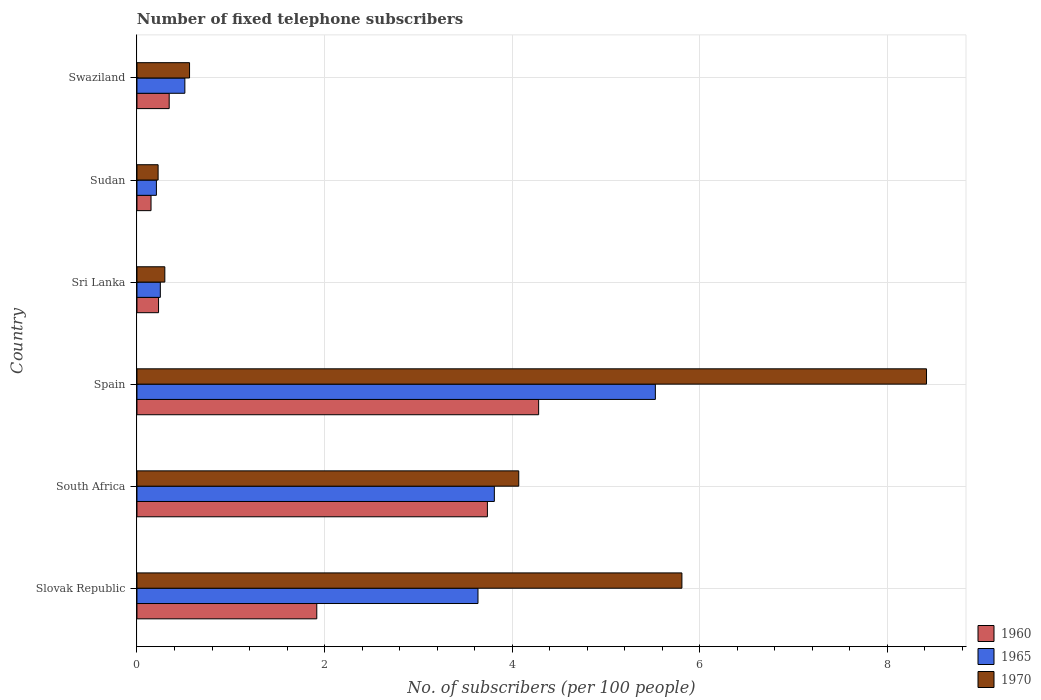How many groups of bars are there?
Keep it short and to the point. 6. Are the number of bars on each tick of the Y-axis equal?
Your answer should be compact. Yes. How many bars are there on the 4th tick from the top?
Provide a short and direct response. 3. What is the label of the 5th group of bars from the top?
Your response must be concise. South Africa. What is the number of fixed telephone subscribers in 1960 in Sudan?
Give a very brief answer. 0.15. Across all countries, what is the maximum number of fixed telephone subscribers in 1960?
Make the answer very short. 4.28. Across all countries, what is the minimum number of fixed telephone subscribers in 1960?
Offer a terse response. 0.15. In which country was the number of fixed telephone subscribers in 1970 maximum?
Offer a terse response. Spain. In which country was the number of fixed telephone subscribers in 1970 minimum?
Your response must be concise. Sudan. What is the total number of fixed telephone subscribers in 1970 in the graph?
Ensure brevity in your answer.  19.38. What is the difference between the number of fixed telephone subscribers in 1965 in Slovak Republic and that in Sri Lanka?
Provide a succinct answer. 3.39. What is the difference between the number of fixed telephone subscribers in 1965 in Spain and the number of fixed telephone subscribers in 1970 in South Africa?
Give a very brief answer. 1.46. What is the average number of fixed telephone subscribers in 1960 per country?
Your answer should be compact. 1.78. What is the difference between the number of fixed telephone subscribers in 1965 and number of fixed telephone subscribers in 1970 in Spain?
Your answer should be very brief. -2.89. What is the ratio of the number of fixed telephone subscribers in 1970 in South Africa to that in Swaziland?
Keep it short and to the point. 7.26. What is the difference between the highest and the second highest number of fixed telephone subscribers in 1960?
Your answer should be compact. 0.55. What is the difference between the highest and the lowest number of fixed telephone subscribers in 1960?
Your response must be concise. 4.13. What does the 3rd bar from the top in South Africa represents?
Your response must be concise. 1960. What does the 1st bar from the bottom in Sri Lanka represents?
Your answer should be compact. 1960. Is it the case that in every country, the sum of the number of fixed telephone subscribers in 1960 and number of fixed telephone subscribers in 1970 is greater than the number of fixed telephone subscribers in 1965?
Make the answer very short. Yes. Are all the bars in the graph horizontal?
Give a very brief answer. Yes. Does the graph contain any zero values?
Keep it short and to the point. No. Where does the legend appear in the graph?
Give a very brief answer. Bottom right. What is the title of the graph?
Make the answer very short. Number of fixed telephone subscribers. Does "1964" appear as one of the legend labels in the graph?
Make the answer very short. No. What is the label or title of the X-axis?
Your response must be concise. No. of subscribers (per 100 people). What is the label or title of the Y-axis?
Your response must be concise. Country. What is the No. of subscribers (per 100 people) in 1960 in Slovak Republic?
Make the answer very short. 1.92. What is the No. of subscribers (per 100 people) of 1965 in Slovak Republic?
Make the answer very short. 3.64. What is the No. of subscribers (per 100 people) of 1970 in Slovak Republic?
Provide a succinct answer. 5.81. What is the No. of subscribers (per 100 people) in 1960 in South Africa?
Provide a short and direct response. 3.74. What is the No. of subscribers (per 100 people) in 1965 in South Africa?
Keep it short and to the point. 3.81. What is the No. of subscribers (per 100 people) of 1970 in South Africa?
Your answer should be compact. 4.07. What is the No. of subscribers (per 100 people) in 1960 in Spain?
Provide a succinct answer. 4.28. What is the No. of subscribers (per 100 people) in 1965 in Spain?
Provide a succinct answer. 5.53. What is the No. of subscribers (per 100 people) of 1970 in Spain?
Your response must be concise. 8.42. What is the No. of subscribers (per 100 people) of 1960 in Sri Lanka?
Your answer should be very brief. 0.23. What is the No. of subscribers (per 100 people) of 1965 in Sri Lanka?
Your answer should be very brief. 0.25. What is the No. of subscribers (per 100 people) of 1970 in Sri Lanka?
Make the answer very short. 0.3. What is the No. of subscribers (per 100 people) of 1960 in Sudan?
Your answer should be compact. 0.15. What is the No. of subscribers (per 100 people) of 1965 in Sudan?
Make the answer very short. 0.21. What is the No. of subscribers (per 100 people) in 1970 in Sudan?
Ensure brevity in your answer.  0.23. What is the No. of subscribers (per 100 people) of 1960 in Swaziland?
Your response must be concise. 0.34. What is the No. of subscribers (per 100 people) in 1965 in Swaziland?
Offer a very short reply. 0.51. What is the No. of subscribers (per 100 people) of 1970 in Swaziland?
Offer a very short reply. 0.56. Across all countries, what is the maximum No. of subscribers (per 100 people) in 1960?
Make the answer very short. 4.28. Across all countries, what is the maximum No. of subscribers (per 100 people) of 1965?
Make the answer very short. 5.53. Across all countries, what is the maximum No. of subscribers (per 100 people) of 1970?
Your response must be concise. 8.42. Across all countries, what is the minimum No. of subscribers (per 100 people) of 1960?
Offer a terse response. 0.15. Across all countries, what is the minimum No. of subscribers (per 100 people) of 1965?
Ensure brevity in your answer.  0.21. Across all countries, what is the minimum No. of subscribers (per 100 people) in 1970?
Give a very brief answer. 0.23. What is the total No. of subscribers (per 100 people) of 1960 in the graph?
Your answer should be very brief. 10.66. What is the total No. of subscribers (per 100 people) in 1965 in the graph?
Keep it short and to the point. 13.94. What is the total No. of subscribers (per 100 people) of 1970 in the graph?
Provide a short and direct response. 19.38. What is the difference between the No. of subscribers (per 100 people) of 1960 in Slovak Republic and that in South Africa?
Your answer should be very brief. -1.82. What is the difference between the No. of subscribers (per 100 people) in 1965 in Slovak Republic and that in South Africa?
Your response must be concise. -0.17. What is the difference between the No. of subscribers (per 100 people) of 1970 in Slovak Republic and that in South Africa?
Ensure brevity in your answer.  1.74. What is the difference between the No. of subscribers (per 100 people) in 1960 in Slovak Republic and that in Spain?
Offer a terse response. -2.37. What is the difference between the No. of subscribers (per 100 people) of 1965 in Slovak Republic and that in Spain?
Your answer should be compact. -1.89. What is the difference between the No. of subscribers (per 100 people) in 1970 in Slovak Republic and that in Spain?
Offer a very short reply. -2.61. What is the difference between the No. of subscribers (per 100 people) of 1960 in Slovak Republic and that in Sri Lanka?
Make the answer very short. 1.69. What is the difference between the No. of subscribers (per 100 people) in 1965 in Slovak Republic and that in Sri Lanka?
Offer a very short reply. 3.39. What is the difference between the No. of subscribers (per 100 people) in 1970 in Slovak Republic and that in Sri Lanka?
Make the answer very short. 5.51. What is the difference between the No. of subscribers (per 100 people) of 1960 in Slovak Republic and that in Sudan?
Make the answer very short. 1.77. What is the difference between the No. of subscribers (per 100 people) of 1965 in Slovak Republic and that in Sudan?
Provide a succinct answer. 3.43. What is the difference between the No. of subscribers (per 100 people) in 1970 in Slovak Republic and that in Sudan?
Give a very brief answer. 5.58. What is the difference between the No. of subscribers (per 100 people) in 1960 in Slovak Republic and that in Swaziland?
Provide a succinct answer. 1.57. What is the difference between the No. of subscribers (per 100 people) in 1965 in Slovak Republic and that in Swaziland?
Keep it short and to the point. 3.13. What is the difference between the No. of subscribers (per 100 people) in 1970 in Slovak Republic and that in Swaziland?
Your answer should be very brief. 5.25. What is the difference between the No. of subscribers (per 100 people) of 1960 in South Africa and that in Spain?
Your response must be concise. -0.55. What is the difference between the No. of subscribers (per 100 people) in 1965 in South Africa and that in Spain?
Offer a very short reply. -1.72. What is the difference between the No. of subscribers (per 100 people) in 1970 in South Africa and that in Spain?
Your response must be concise. -4.35. What is the difference between the No. of subscribers (per 100 people) in 1960 in South Africa and that in Sri Lanka?
Offer a terse response. 3.51. What is the difference between the No. of subscribers (per 100 people) of 1965 in South Africa and that in Sri Lanka?
Provide a succinct answer. 3.56. What is the difference between the No. of subscribers (per 100 people) of 1970 in South Africa and that in Sri Lanka?
Your answer should be compact. 3.77. What is the difference between the No. of subscribers (per 100 people) of 1960 in South Africa and that in Sudan?
Your answer should be very brief. 3.59. What is the difference between the No. of subscribers (per 100 people) of 1965 in South Africa and that in Sudan?
Keep it short and to the point. 3.6. What is the difference between the No. of subscribers (per 100 people) in 1970 in South Africa and that in Sudan?
Give a very brief answer. 3.85. What is the difference between the No. of subscribers (per 100 people) of 1960 in South Africa and that in Swaziland?
Your answer should be compact. 3.39. What is the difference between the No. of subscribers (per 100 people) in 1965 in South Africa and that in Swaziland?
Your answer should be compact. 3.3. What is the difference between the No. of subscribers (per 100 people) of 1970 in South Africa and that in Swaziland?
Make the answer very short. 3.51. What is the difference between the No. of subscribers (per 100 people) in 1960 in Spain and that in Sri Lanka?
Keep it short and to the point. 4.05. What is the difference between the No. of subscribers (per 100 people) in 1965 in Spain and that in Sri Lanka?
Provide a succinct answer. 5.28. What is the difference between the No. of subscribers (per 100 people) of 1970 in Spain and that in Sri Lanka?
Provide a short and direct response. 8.12. What is the difference between the No. of subscribers (per 100 people) in 1960 in Spain and that in Sudan?
Offer a very short reply. 4.13. What is the difference between the No. of subscribers (per 100 people) in 1965 in Spain and that in Sudan?
Keep it short and to the point. 5.32. What is the difference between the No. of subscribers (per 100 people) in 1970 in Spain and that in Sudan?
Provide a succinct answer. 8.19. What is the difference between the No. of subscribers (per 100 people) in 1960 in Spain and that in Swaziland?
Ensure brevity in your answer.  3.94. What is the difference between the No. of subscribers (per 100 people) in 1965 in Spain and that in Swaziland?
Give a very brief answer. 5.02. What is the difference between the No. of subscribers (per 100 people) in 1970 in Spain and that in Swaziland?
Offer a terse response. 7.86. What is the difference between the No. of subscribers (per 100 people) in 1960 in Sri Lanka and that in Sudan?
Offer a very short reply. 0.08. What is the difference between the No. of subscribers (per 100 people) in 1965 in Sri Lanka and that in Sudan?
Ensure brevity in your answer.  0.04. What is the difference between the No. of subscribers (per 100 people) of 1970 in Sri Lanka and that in Sudan?
Provide a succinct answer. 0.07. What is the difference between the No. of subscribers (per 100 people) of 1960 in Sri Lanka and that in Swaziland?
Provide a succinct answer. -0.11. What is the difference between the No. of subscribers (per 100 people) of 1965 in Sri Lanka and that in Swaziland?
Provide a short and direct response. -0.26. What is the difference between the No. of subscribers (per 100 people) of 1970 in Sri Lanka and that in Swaziland?
Your answer should be compact. -0.26. What is the difference between the No. of subscribers (per 100 people) in 1960 in Sudan and that in Swaziland?
Provide a short and direct response. -0.19. What is the difference between the No. of subscribers (per 100 people) of 1965 in Sudan and that in Swaziland?
Provide a succinct answer. -0.3. What is the difference between the No. of subscribers (per 100 people) in 1970 in Sudan and that in Swaziland?
Your response must be concise. -0.34. What is the difference between the No. of subscribers (per 100 people) in 1960 in Slovak Republic and the No. of subscribers (per 100 people) in 1965 in South Africa?
Your answer should be very brief. -1.89. What is the difference between the No. of subscribers (per 100 people) of 1960 in Slovak Republic and the No. of subscribers (per 100 people) of 1970 in South Africa?
Offer a terse response. -2.15. What is the difference between the No. of subscribers (per 100 people) in 1965 in Slovak Republic and the No. of subscribers (per 100 people) in 1970 in South Africa?
Give a very brief answer. -0.43. What is the difference between the No. of subscribers (per 100 people) in 1960 in Slovak Republic and the No. of subscribers (per 100 people) in 1965 in Spain?
Keep it short and to the point. -3.61. What is the difference between the No. of subscribers (per 100 people) of 1960 in Slovak Republic and the No. of subscribers (per 100 people) of 1970 in Spain?
Offer a terse response. -6.5. What is the difference between the No. of subscribers (per 100 people) of 1965 in Slovak Republic and the No. of subscribers (per 100 people) of 1970 in Spain?
Provide a short and direct response. -4.78. What is the difference between the No. of subscribers (per 100 people) in 1960 in Slovak Republic and the No. of subscribers (per 100 people) in 1965 in Sri Lanka?
Keep it short and to the point. 1.67. What is the difference between the No. of subscribers (per 100 people) of 1960 in Slovak Republic and the No. of subscribers (per 100 people) of 1970 in Sri Lanka?
Ensure brevity in your answer.  1.62. What is the difference between the No. of subscribers (per 100 people) of 1965 in Slovak Republic and the No. of subscribers (per 100 people) of 1970 in Sri Lanka?
Keep it short and to the point. 3.34. What is the difference between the No. of subscribers (per 100 people) in 1960 in Slovak Republic and the No. of subscribers (per 100 people) in 1965 in Sudan?
Ensure brevity in your answer.  1.71. What is the difference between the No. of subscribers (per 100 people) in 1960 in Slovak Republic and the No. of subscribers (per 100 people) in 1970 in Sudan?
Give a very brief answer. 1.69. What is the difference between the No. of subscribers (per 100 people) of 1965 in Slovak Republic and the No. of subscribers (per 100 people) of 1970 in Sudan?
Give a very brief answer. 3.41. What is the difference between the No. of subscribers (per 100 people) of 1960 in Slovak Republic and the No. of subscribers (per 100 people) of 1965 in Swaziland?
Provide a short and direct response. 1.41. What is the difference between the No. of subscribers (per 100 people) in 1960 in Slovak Republic and the No. of subscribers (per 100 people) in 1970 in Swaziland?
Ensure brevity in your answer.  1.36. What is the difference between the No. of subscribers (per 100 people) in 1965 in Slovak Republic and the No. of subscribers (per 100 people) in 1970 in Swaziland?
Offer a very short reply. 3.08. What is the difference between the No. of subscribers (per 100 people) in 1960 in South Africa and the No. of subscribers (per 100 people) in 1965 in Spain?
Offer a terse response. -1.79. What is the difference between the No. of subscribers (per 100 people) in 1960 in South Africa and the No. of subscribers (per 100 people) in 1970 in Spain?
Ensure brevity in your answer.  -4.68. What is the difference between the No. of subscribers (per 100 people) of 1965 in South Africa and the No. of subscribers (per 100 people) of 1970 in Spain?
Your response must be concise. -4.61. What is the difference between the No. of subscribers (per 100 people) in 1960 in South Africa and the No. of subscribers (per 100 people) in 1965 in Sri Lanka?
Make the answer very short. 3.49. What is the difference between the No. of subscribers (per 100 people) of 1960 in South Africa and the No. of subscribers (per 100 people) of 1970 in Sri Lanka?
Your response must be concise. 3.44. What is the difference between the No. of subscribers (per 100 people) of 1965 in South Africa and the No. of subscribers (per 100 people) of 1970 in Sri Lanka?
Provide a succinct answer. 3.51. What is the difference between the No. of subscribers (per 100 people) of 1960 in South Africa and the No. of subscribers (per 100 people) of 1965 in Sudan?
Ensure brevity in your answer.  3.53. What is the difference between the No. of subscribers (per 100 people) of 1960 in South Africa and the No. of subscribers (per 100 people) of 1970 in Sudan?
Your answer should be very brief. 3.51. What is the difference between the No. of subscribers (per 100 people) of 1965 in South Africa and the No. of subscribers (per 100 people) of 1970 in Sudan?
Offer a terse response. 3.58. What is the difference between the No. of subscribers (per 100 people) in 1960 in South Africa and the No. of subscribers (per 100 people) in 1965 in Swaziland?
Your answer should be very brief. 3.23. What is the difference between the No. of subscribers (per 100 people) of 1960 in South Africa and the No. of subscribers (per 100 people) of 1970 in Swaziland?
Give a very brief answer. 3.18. What is the difference between the No. of subscribers (per 100 people) of 1965 in South Africa and the No. of subscribers (per 100 people) of 1970 in Swaziland?
Give a very brief answer. 3.25. What is the difference between the No. of subscribers (per 100 people) of 1960 in Spain and the No. of subscribers (per 100 people) of 1965 in Sri Lanka?
Keep it short and to the point. 4.03. What is the difference between the No. of subscribers (per 100 people) of 1960 in Spain and the No. of subscribers (per 100 people) of 1970 in Sri Lanka?
Offer a very short reply. 3.99. What is the difference between the No. of subscribers (per 100 people) of 1965 in Spain and the No. of subscribers (per 100 people) of 1970 in Sri Lanka?
Offer a very short reply. 5.23. What is the difference between the No. of subscribers (per 100 people) in 1960 in Spain and the No. of subscribers (per 100 people) in 1965 in Sudan?
Make the answer very short. 4.08. What is the difference between the No. of subscribers (per 100 people) in 1960 in Spain and the No. of subscribers (per 100 people) in 1970 in Sudan?
Make the answer very short. 4.06. What is the difference between the No. of subscribers (per 100 people) in 1965 in Spain and the No. of subscribers (per 100 people) in 1970 in Sudan?
Provide a succinct answer. 5.3. What is the difference between the No. of subscribers (per 100 people) in 1960 in Spain and the No. of subscribers (per 100 people) in 1965 in Swaziland?
Offer a terse response. 3.77. What is the difference between the No. of subscribers (per 100 people) of 1960 in Spain and the No. of subscribers (per 100 people) of 1970 in Swaziland?
Give a very brief answer. 3.72. What is the difference between the No. of subscribers (per 100 people) of 1965 in Spain and the No. of subscribers (per 100 people) of 1970 in Swaziland?
Provide a short and direct response. 4.97. What is the difference between the No. of subscribers (per 100 people) of 1960 in Sri Lanka and the No. of subscribers (per 100 people) of 1965 in Sudan?
Your answer should be compact. 0.02. What is the difference between the No. of subscribers (per 100 people) in 1960 in Sri Lanka and the No. of subscribers (per 100 people) in 1970 in Sudan?
Offer a very short reply. 0. What is the difference between the No. of subscribers (per 100 people) of 1965 in Sri Lanka and the No. of subscribers (per 100 people) of 1970 in Sudan?
Keep it short and to the point. 0.02. What is the difference between the No. of subscribers (per 100 people) of 1960 in Sri Lanka and the No. of subscribers (per 100 people) of 1965 in Swaziland?
Make the answer very short. -0.28. What is the difference between the No. of subscribers (per 100 people) in 1960 in Sri Lanka and the No. of subscribers (per 100 people) in 1970 in Swaziland?
Make the answer very short. -0.33. What is the difference between the No. of subscribers (per 100 people) in 1965 in Sri Lanka and the No. of subscribers (per 100 people) in 1970 in Swaziland?
Ensure brevity in your answer.  -0.31. What is the difference between the No. of subscribers (per 100 people) in 1960 in Sudan and the No. of subscribers (per 100 people) in 1965 in Swaziland?
Your response must be concise. -0.36. What is the difference between the No. of subscribers (per 100 people) of 1960 in Sudan and the No. of subscribers (per 100 people) of 1970 in Swaziland?
Give a very brief answer. -0.41. What is the difference between the No. of subscribers (per 100 people) in 1965 in Sudan and the No. of subscribers (per 100 people) in 1970 in Swaziland?
Offer a terse response. -0.35. What is the average No. of subscribers (per 100 people) of 1960 per country?
Offer a very short reply. 1.78. What is the average No. of subscribers (per 100 people) of 1965 per country?
Your answer should be very brief. 2.32. What is the average No. of subscribers (per 100 people) in 1970 per country?
Make the answer very short. 3.23. What is the difference between the No. of subscribers (per 100 people) in 1960 and No. of subscribers (per 100 people) in 1965 in Slovak Republic?
Ensure brevity in your answer.  -1.72. What is the difference between the No. of subscribers (per 100 people) in 1960 and No. of subscribers (per 100 people) in 1970 in Slovak Republic?
Ensure brevity in your answer.  -3.89. What is the difference between the No. of subscribers (per 100 people) in 1965 and No. of subscribers (per 100 people) in 1970 in Slovak Republic?
Offer a terse response. -2.17. What is the difference between the No. of subscribers (per 100 people) in 1960 and No. of subscribers (per 100 people) in 1965 in South Africa?
Your answer should be very brief. -0.07. What is the difference between the No. of subscribers (per 100 people) of 1960 and No. of subscribers (per 100 people) of 1970 in South Africa?
Ensure brevity in your answer.  -0.33. What is the difference between the No. of subscribers (per 100 people) of 1965 and No. of subscribers (per 100 people) of 1970 in South Africa?
Your answer should be very brief. -0.26. What is the difference between the No. of subscribers (per 100 people) in 1960 and No. of subscribers (per 100 people) in 1965 in Spain?
Your response must be concise. -1.24. What is the difference between the No. of subscribers (per 100 people) of 1960 and No. of subscribers (per 100 people) of 1970 in Spain?
Provide a short and direct response. -4.14. What is the difference between the No. of subscribers (per 100 people) in 1965 and No. of subscribers (per 100 people) in 1970 in Spain?
Give a very brief answer. -2.89. What is the difference between the No. of subscribers (per 100 people) in 1960 and No. of subscribers (per 100 people) in 1965 in Sri Lanka?
Your answer should be very brief. -0.02. What is the difference between the No. of subscribers (per 100 people) in 1960 and No. of subscribers (per 100 people) in 1970 in Sri Lanka?
Offer a terse response. -0.07. What is the difference between the No. of subscribers (per 100 people) in 1965 and No. of subscribers (per 100 people) in 1970 in Sri Lanka?
Give a very brief answer. -0.05. What is the difference between the No. of subscribers (per 100 people) in 1960 and No. of subscribers (per 100 people) in 1965 in Sudan?
Offer a terse response. -0.06. What is the difference between the No. of subscribers (per 100 people) in 1960 and No. of subscribers (per 100 people) in 1970 in Sudan?
Your answer should be very brief. -0.08. What is the difference between the No. of subscribers (per 100 people) in 1965 and No. of subscribers (per 100 people) in 1970 in Sudan?
Offer a terse response. -0.02. What is the difference between the No. of subscribers (per 100 people) of 1960 and No. of subscribers (per 100 people) of 1965 in Swaziland?
Your response must be concise. -0.17. What is the difference between the No. of subscribers (per 100 people) of 1960 and No. of subscribers (per 100 people) of 1970 in Swaziland?
Keep it short and to the point. -0.22. What is the difference between the No. of subscribers (per 100 people) in 1965 and No. of subscribers (per 100 people) in 1970 in Swaziland?
Keep it short and to the point. -0.05. What is the ratio of the No. of subscribers (per 100 people) of 1960 in Slovak Republic to that in South Africa?
Make the answer very short. 0.51. What is the ratio of the No. of subscribers (per 100 people) of 1965 in Slovak Republic to that in South Africa?
Offer a very short reply. 0.95. What is the ratio of the No. of subscribers (per 100 people) in 1970 in Slovak Republic to that in South Africa?
Make the answer very short. 1.43. What is the ratio of the No. of subscribers (per 100 people) in 1960 in Slovak Republic to that in Spain?
Your answer should be compact. 0.45. What is the ratio of the No. of subscribers (per 100 people) of 1965 in Slovak Republic to that in Spain?
Your answer should be compact. 0.66. What is the ratio of the No. of subscribers (per 100 people) of 1970 in Slovak Republic to that in Spain?
Offer a very short reply. 0.69. What is the ratio of the No. of subscribers (per 100 people) in 1960 in Slovak Republic to that in Sri Lanka?
Provide a short and direct response. 8.33. What is the ratio of the No. of subscribers (per 100 people) of 1965 in Slovak Republic to that in Sri Lanka?
Your answer should be compact. 14.59. What is the ratio of the No. of subscribers (per 100 people) of 1970 in Slovak Republic to that in Sri Lanka?
Provide a succinct answer. 19.55. What is the ratio of the No. of subscribers (per 100 people) of 1960 in Slovak Republic to that in Sudan?
Give a very brief answer. 12.78. What is the ratio of the No. of subscribers (per 100 people) of 1965 in Slovak Republic to that in Sudan?
Your response must be concise. 17.53. What is the ratio of the No. of subscribers (per 100 people) of 1970 in Slovak Republic to that in Sudan?
Make the answer very short. 25.76. What is the ratio of the No. of subscribers (per 100 people) of 1960 in Slovak Republic to that in Swaziland?
Provide a succinct answer. 5.58. What is the ratio of the No. of subscribers (per 100 people) in 1965 in Slovak Republic to that in Swaziland?
Offer a terse response. 7.12. What is the ratio of the No. of subscribers (per 100 people) of 1970 in Slovak Republic to that in Swaziland?
Make the answer very short. 10.36. What is the ratio of the No. of subscribers (per 100 people) of 1960 in South Africa to that in Spain?
Ensure brevity in your answer.  0.87. What is the ratio of the No. of subscribers (per 100 people) in 1965 in South Africa to that in Spain?
Ensure brevity in your answer.  0.69. What is the ratio of the No. of subscribers (per 100 people) in 1970 in South Africa to that in Spain?
Provide a short and direct response. 0.48. What is the ratio of the No. of subscribers (per 100 people) in 1960 in South Africa to that in Sri Lanka?
Your response must be concise. 16.24. What is the ratio of the No. of subscribers (per 100 people) of 1965 in South Africa to that in Sri Lanka?
Make the answer very short. 15.29. What is the ratio of the No. of subscribers (per 100 people) of 1970 in South Africa to that in Sri Lanka?
Provide a short and direct response. 13.7. What is the ratio of the No. of subscribers (per 100 people) of 1960 in South Africa to that in Sudan?
Your answer should be compact. 24.92. What is the ratio of the No. of subscribers (per 100 people) in 1965 in South Africa to that in Sudan?
Provide a short and direct response. 18.38. What is the ratio of the No. of subscribers (per 100 people) of 1970 in South Africa to that in Sudan?
Give a very brief answer. 18.05. What is the ratio of the No. of subscribers (per 100 people) in 1960 in South Africa to that in Swaziland?
Offer a very short reply. 10.87. What is the ratio of the No. of subscribers (per 100 people) in 1965 in South Africa to that in Swaziland?
Your answer should be compact. 7.46. What is the ratio of the No. of subscribers (per 100 people) of 1970 in South Africa to that in Swaziland?
Ensure brevity in your answer.  7.26. What is the ratio of the No. of subscribers (per 100 people) in 1960 in Spain to that in Sri Lanka?
Offer a terse response. 18.61. What is the ratio of the No. of subscribers (per 100 people) in 1965 in Spain to that in Sri Lanka?
Keep it short and to the point. 22.18. What is the ratio of the No. of subscribers (per 100 people) in 1970 in Spain to that in Sri Lanka?
Keep it short and to the point. 28.33. What is the ratio of the No. of subscribers (per 100 people) of 1960 in Spain to that in Sudan?
Your response must be concise. 28.56. What is the ratio of the No. of subscribers (per 100 people) of 1965 in Spain to that in Sudan?
Provide a succinct answer. 26.65. What is the ratio of the No. of subscribers (per 100 people) of 1970 in Spain to that in Sudan?
Provide a short and direct response. 37.33. What is the ratio of the No. of subscribers (per 100 people) in 1960 in Spain to that in Swaziland?
Your answer should be very brief. 12.46. What is the ratio of the No. of subscribers (per 100 people) in 1965 in Spain to that in Swaziland?
Offer a terse response. 10.82. What is the ratio of the No. of subscribers (per 100 people) of 1970 in Spain to that in Swaziland?
Offer a terse response. 15.01. What is the ratio of the No. of subscribers (per 100 people) in 1960 in Sri Lanka to that in Sudan?
Your response must be concise. 1.53. What is the ratio of the No. of subscribers (per 100 people) of 1965 in Sri Lanka to that in Sudan?
Provide a short and direct response. 1.2. What is the ratio of the No. of subscribers (per 100 people) of 1970 in Sri Lanka to that in Sudan?
Provide a succinct answer. 1.32. What is the ratio of the No. of subscribers (per 100 people) of 1960 in Sri Lanka to that in Swaziland?
Provide a succinct answer. 0.67. What is the ratio of the No. of subscribers (per 100 people) of 1965 in Sri Lanka to that in Swaziland?
Give a very brief answer. 0.49. What is the ratio of the No. of subscribers (per 100 people) of 1970 in Sri Lanka to that in Swaziland?
Offer a very short reply. 0.53. What is the ratio of the No. of subscribers (per 100 people) of 1960 in Sudan to that in Swaziland?
Ensure brevity in your answer.  0.44. What is the ratio of the No. of subscribers (per 100 people) in 1965 in Sudan to that in Swaziland?
Give a very brief answer. 0.41. What is the ratio of the No. of subscribers (per 100 people) in 1970 in Sudan to that in Swaziland?
Provide a short and direct response. 0.4. What is the difference between the highest and the second highest No. of subscribers (per 100 people) in 1960?
Offer a very short reply. 0.55. What is the difference between the highest and the second highest No. of subscribers (per 100 people) in 1965?
Offer a terse response. 1.72. What is the difference between the highest and the second highest No. of subscribers (per 100 people) of 1970?
Keep it short and to the point. 2.61. What is the difference between the highest and the lowest No. of subscribers (per 100 people) of 1960?
Your response must be concise. 4.13. What is the difference between the highest and the lowest No. of subscribers (per 100 people) of 1965?
Offer a terse response. 5.32. What is the difference between the highest and the lowest No. of subscribers (per 100 people) of 1970?
Your answer should be very brief. 8.19. 